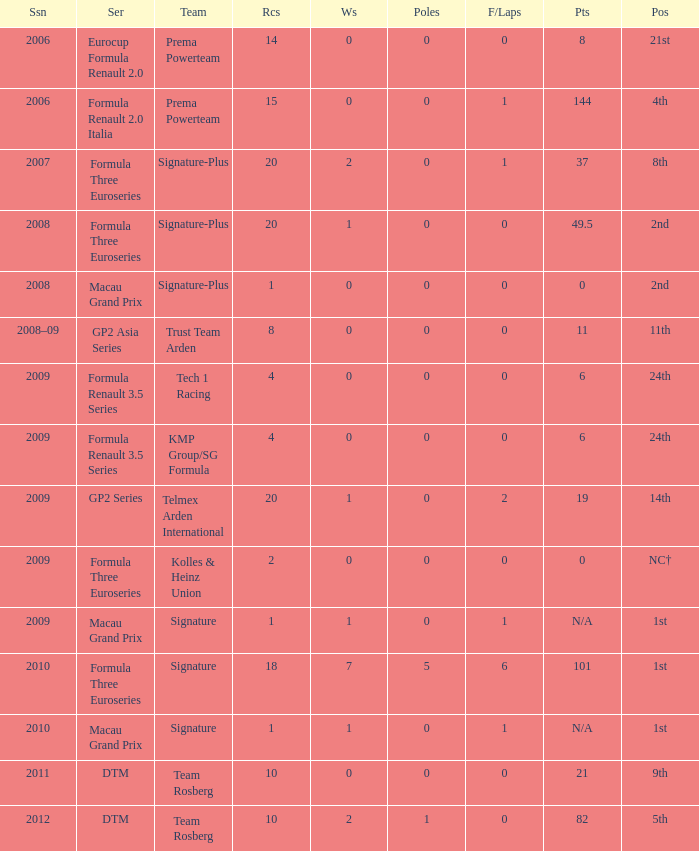Which series has 11 points? GP2 Asia Series. 